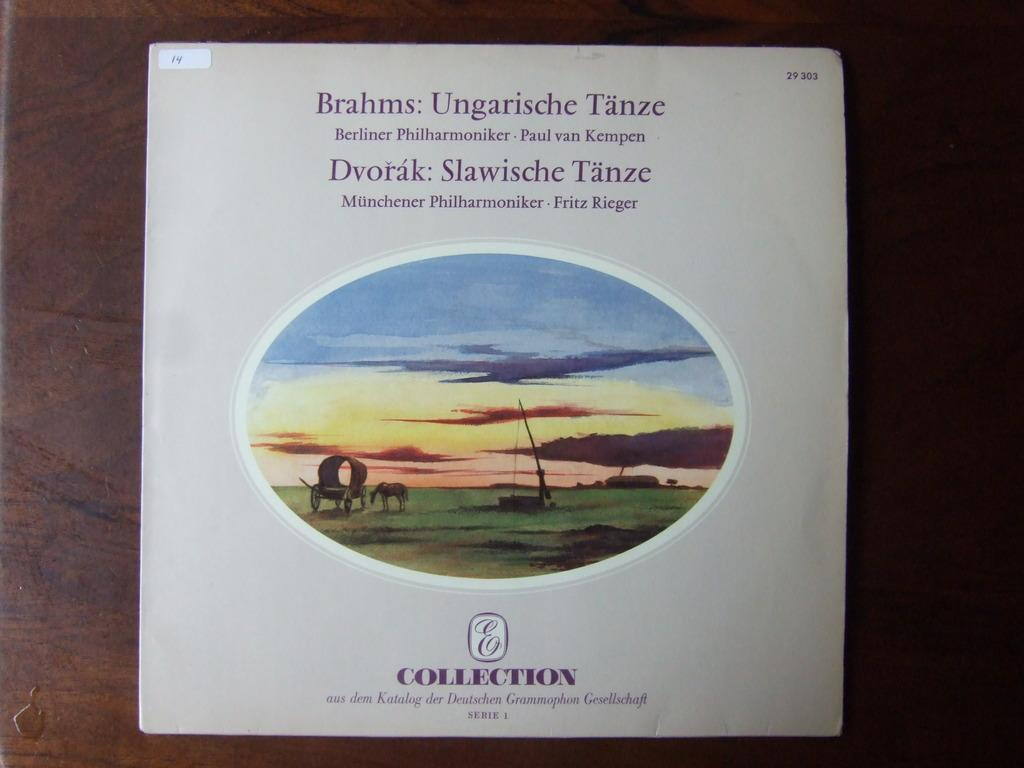Provide a one-sentence caption for the provided image. A record album of classical music is part of the E Collection. 